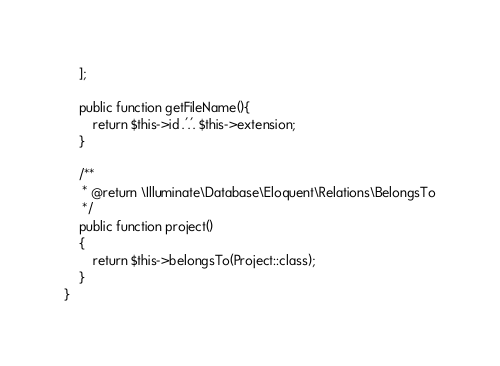<code> <loc_0><loc_0><loc_500><loc_500><_PHP_>    ];

    public function getFileName(){
        return $this->id .'.'. $this->extension;
    }

    /**
     * @return \Illuminate\Database\Eloquent\Relations\BelongsTo
     */
    public function project()
    {
        return $this->belongsTo(Project::class);
    }
}
</code> 